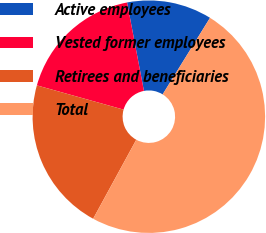<chart> <loc_0><loc_0><loc_500><loc_500><pie_chart><fcel>Active employees<fcel>Vested former employees<fcel>Retirees and beneficiaries<fcel>Total<nl><fcel>11.82%<fcel>17.66%<fcel>21.39%<fcel>49.13%<nl></chart> 